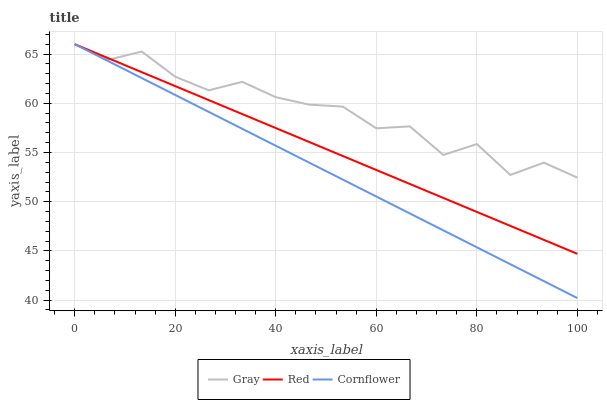Does Red have the minimum area under the curve?
Answer yes or no. No. Does Red have the maximum area under the curve?
Answer yes or no. No. Is Red the smoothest?
Answer yes or no. No. Is Red the roughest?
Answer yes or no. No. Does Red have the lowest value?
Answer yes or no. No. 